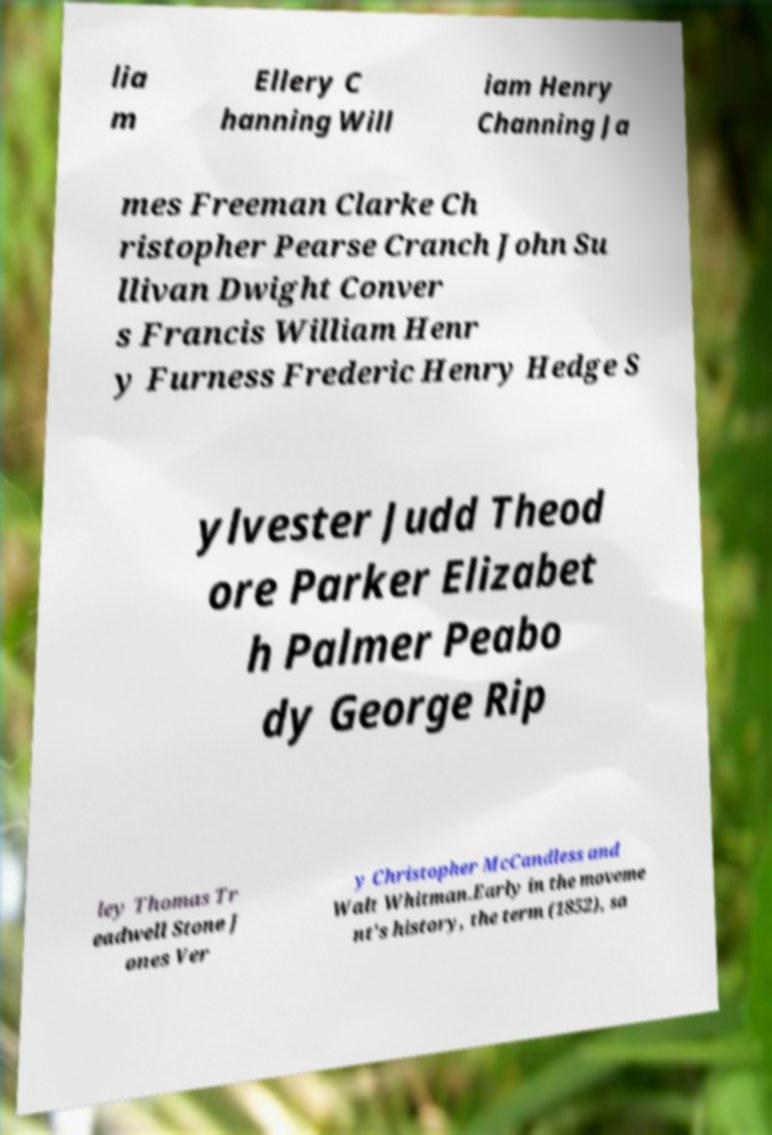For documentation purposes, I need the text within this image transcribed. Could you provide that? lia m Ellery C hanning Will iam Henry Channing Ja mes Freeman Clarke Ch ristopher Pearse Cranch John Su llivan Dwight Conver s Francis William Henr y Furness Frederic Henry Hedge S ylvester Judd Theod ore Parker Elizabet h Palmer Peabo dy George Rip ley Thomas Tr eadwell Stone J ones Ver y Christopher McCandless and Walt Whitman.Early in the moveme nt's history, the term (1852), sa 